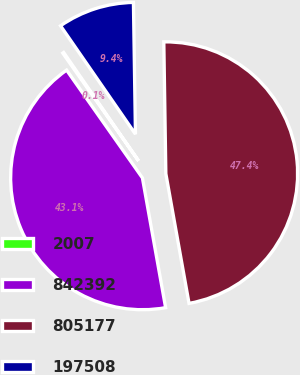Convert chart to OTSL. <chart><loc_0><loc_0><loc_500><loc_500><pie_chart><fcel>2007<fcel>842392<fcel>805177<fcel>197508<nl><fcel>0.13%<fcel>43.06%<fcel>47.43%<fcel>9.38%<nl></chart> 